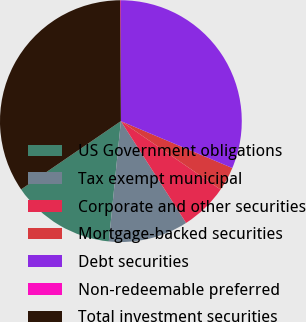Convert chart to OTSL. <chart><loc_0><loc_0><loc_500><loc_500><pie_chart><fcel>US Government obligations<fcel>Tax exempt municipal<fcel>Corporate and other securities<fcel>Mortgage-backed securities<fcel>Debt securities<fcel>Non-redeemable preferred<fcel>Total investment securities<nl><fcel>13.86%<fcel>10.66%<fcel>6.36%<fcel>3.23%<fcel>31.32%<fcel>0.1%<fcel>34.46%<nl></chart> 